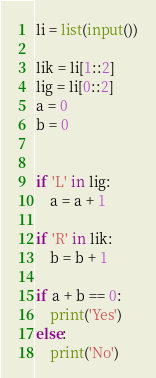<code> <loc_0><loc_0><loc_500><loc_500><_Python_>li = list(input())

lik = li[1::2]
lig = li[0::2]
a = 0
b = 0


if 'L' in lig:
    a = a + 1

if 'R' in lik:
    b = b + 1

if a + b == 0:
    print('Yes')
else:
    print('No')</code> 